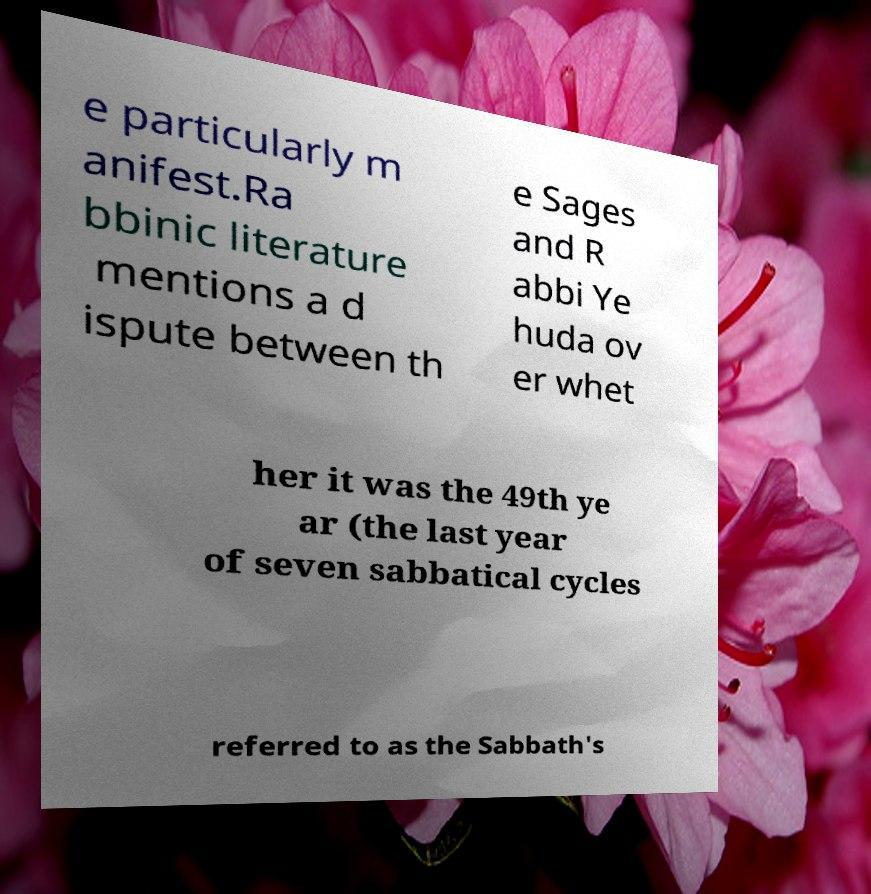Can you read and provide the text displayed in the image?This photo seems to have some interesting text. Can you extract and type it out for me? e particularly m anifest.Ra bbinic literature mentions a d ispute between th e Sages and R abbi Ye huda ov er whet her it was the 49th ye ar (the last year of seven sabbatical cycles referred to as the Sabbath's 